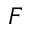Convert formula to latex. <formula><loc_0><loc_0><loc_500><loc_500>F</formula> 